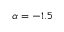Convert formula to latex. <formula><loc_0><loc_0><loc_500><loc_500>\alpha = - 1 . 5</formula> 